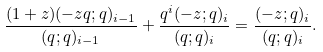Convert formula to latex. <formula><loc_0><loc_0><loc_500><loc_500>\frac { ( 1 + z ) ( - z q ; q ) _ { i - 1 } } { ( q ; q ) _ { i - 1 } } + \frac { q ^ { i } ( - z ; q ) _ { i } } { ( q ; q ) _ { i } } = \frac { ( - z ; q ) _ { i } } { ( q ; q ) _ { i } } .</formula> 